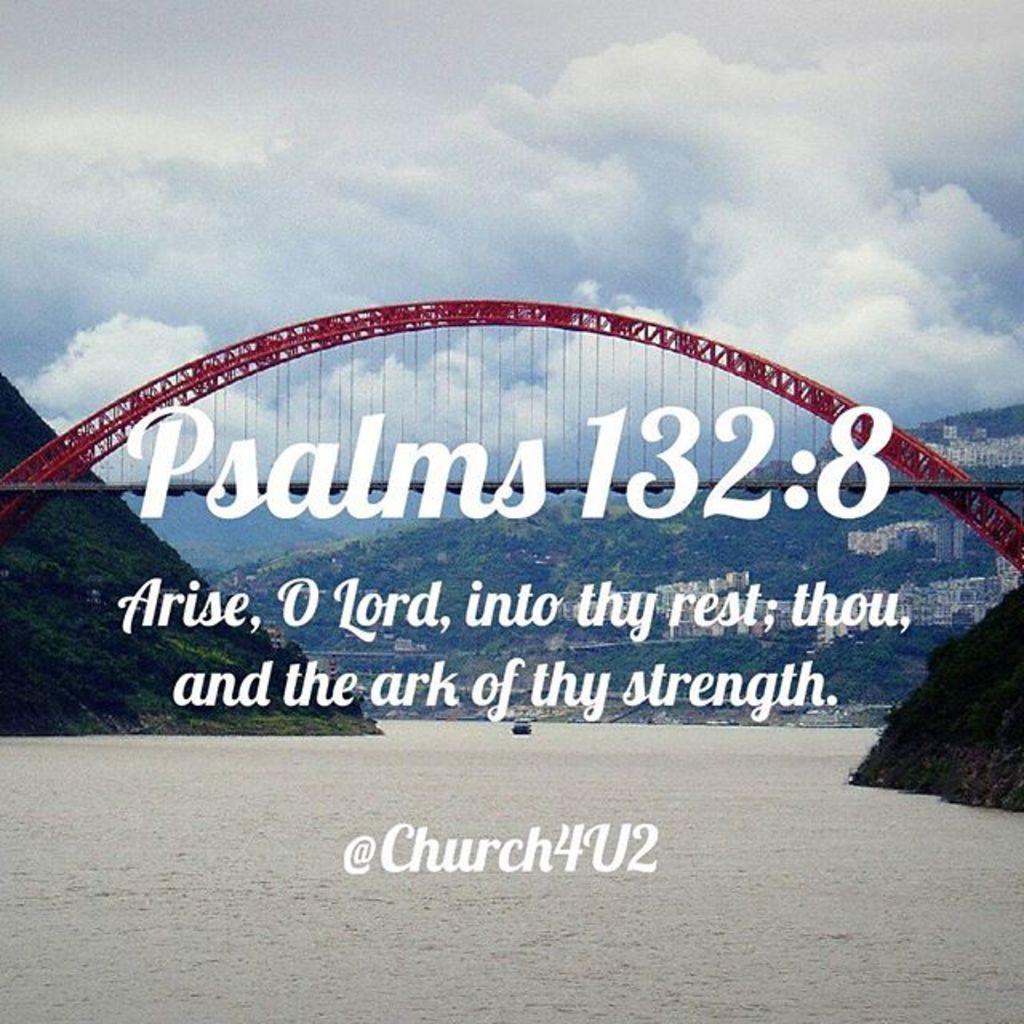Which psalms is being quoted?
Your response must be concise. 132:8. 